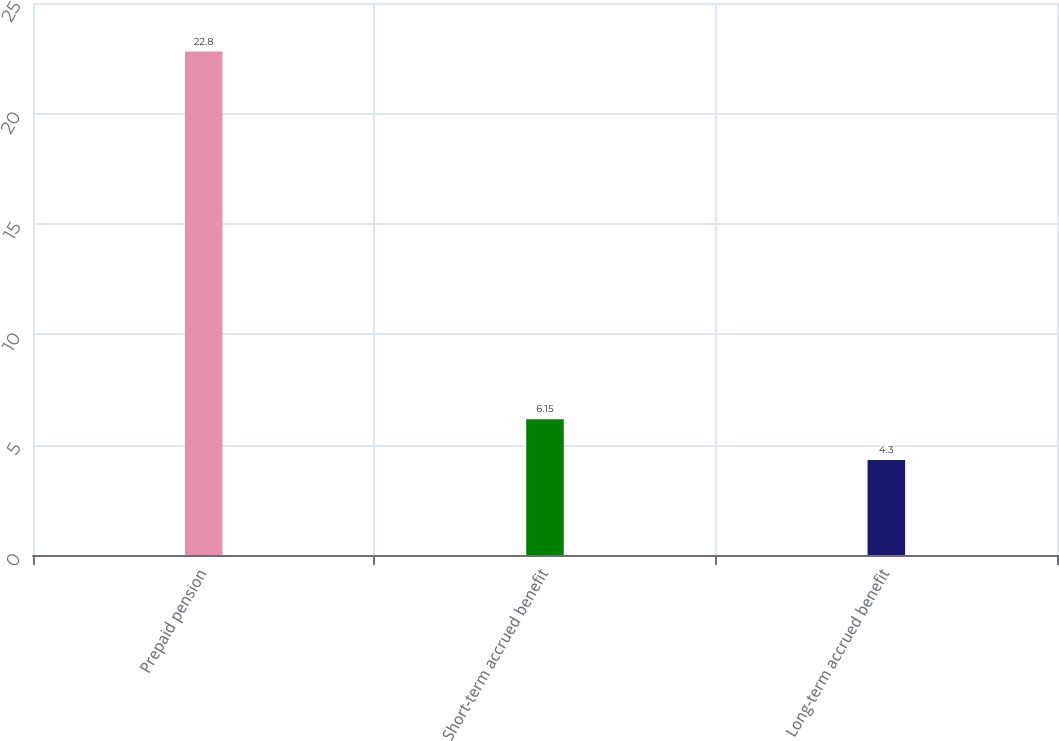Convert chart. <chart><loc_0><loc_0><loc_500><loc_500><bar_chart><fcel>Prepaid pension<fcel>Short-term accrued benefit<fcel>Long-term accrued benefit<nl><fcel>22.8<fcel>6.15<fcel>4.3<nl></chart> 